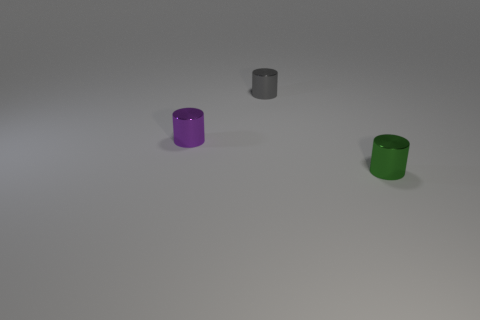Add 2 small metal spheres. How many objects exist? 5 Subtract all green objects. Subtract all cyan rubber cylinders. How many objects are left? 2 Add 1 tiny green things. How many tiny green things are left? 2 Add 1 tiny purple cylinders. How many tiny purple cylinders exist? 2 Subtract 0 yellow blocks. How many objects are left? 3 